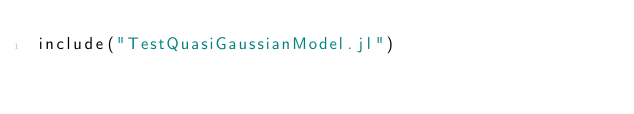Convert code to text. <code><loc_0><loc_0><loc_500><loc_500><_Julia_>include("TestQuasiGaussianModel.jl")


</code> 